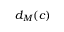<formula> <loc_0><loc_0><loc_500><loc_500>d _ { M } ( c )</formula> 